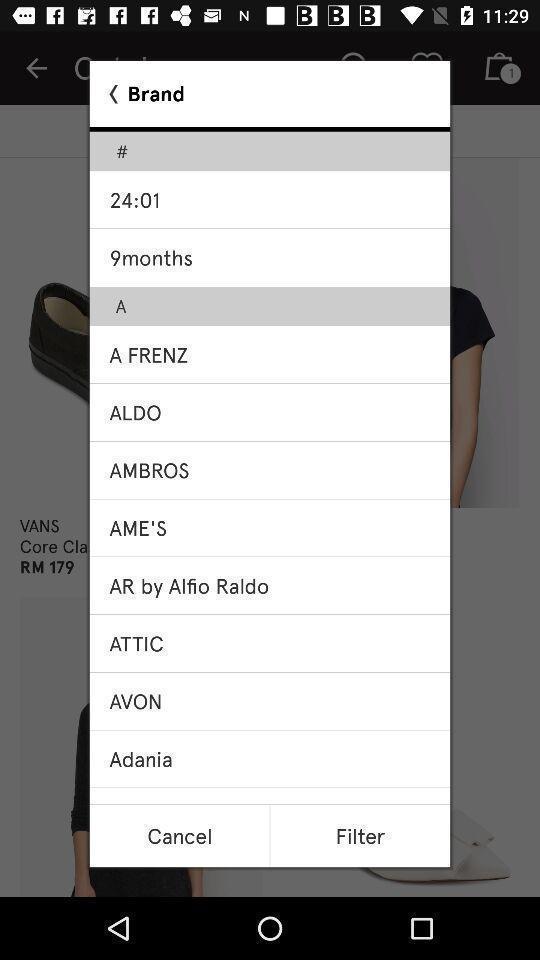Please provide a description for this image. Pop-up showing list various brands in a shopping app. 